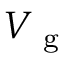Convert formula to latex. <formula><loc_0><loc_0><loc_500><loc_500>V _ { g }</formula> 